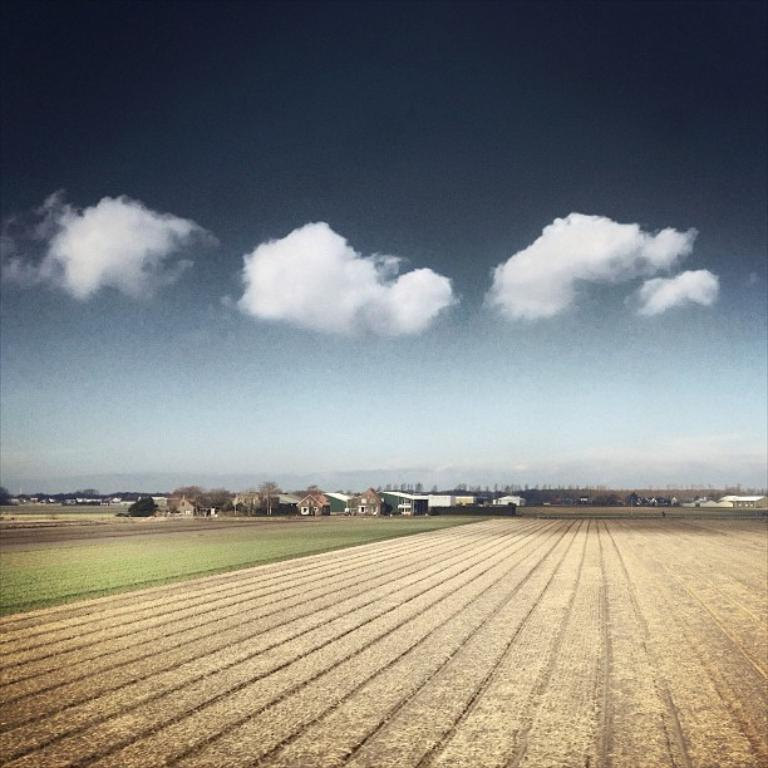What type of landscape is shown in the image? The image depicts an open land. Are there any structures visible in the background? Yes, there are houses in the background of the image. What can be seen in the sky in the image? There are clouds visible in the sky. What type of music can be heard playing in the image? There is no music present in the image, as it is a visual representation of an open land with houses in the background and clouds in the sky. 